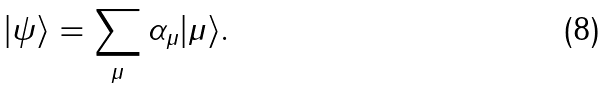Convert formula to latex. <formula><loc_0><loc_0><loc_500><loc_500>| \psi \rangle = \sum _ { \mu } \alpha _ { \mu } | \mu \rangle .</formula> 